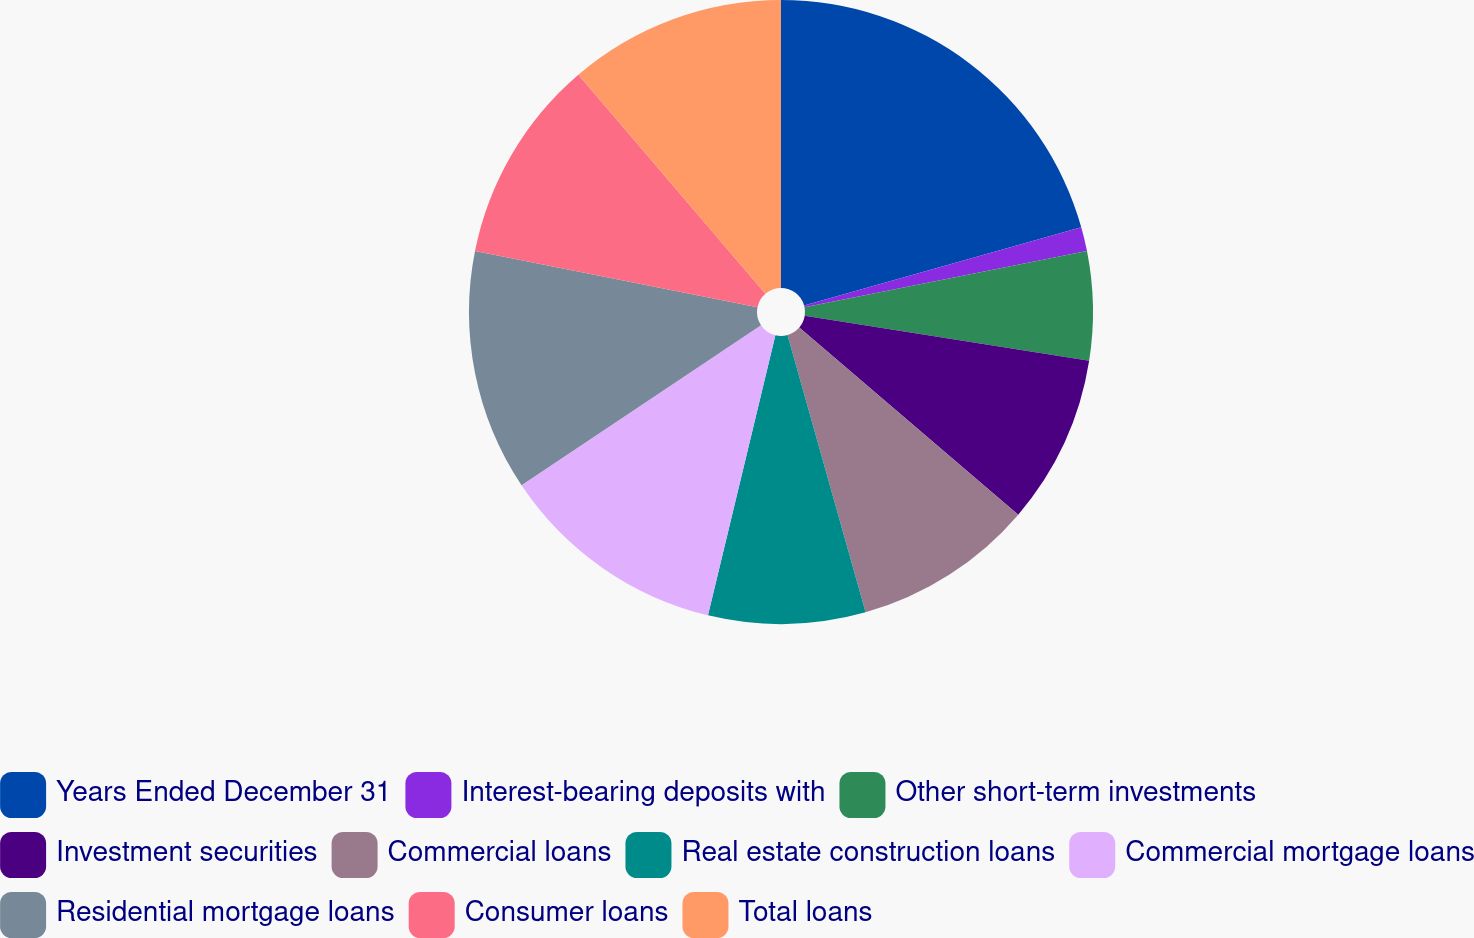Convert chart. <chart><loc_0><loc_0><loc_500><loc_500><pie_chart><fcel>Years Ended December 31<fcel>Interest-bearing deposits with<fcel>Other short-term investments<fcel>Investment securities<fcel>Commercial loans<fcel>Real estate construction loans<fcel>Commercial mortgage loans<fcel>Residential mortgage loans<fcel>Consumer loans<fcel>Total loans<nl><fcel>20.62%<fcel>1.25%<fcel>5.63%<fcel>8.75%<fcel>9.38%<fcel>8.13%<fcel>11.87%<fcel>12.5%<fcel>10.62%<fcel>11.25%<nl></chart> 